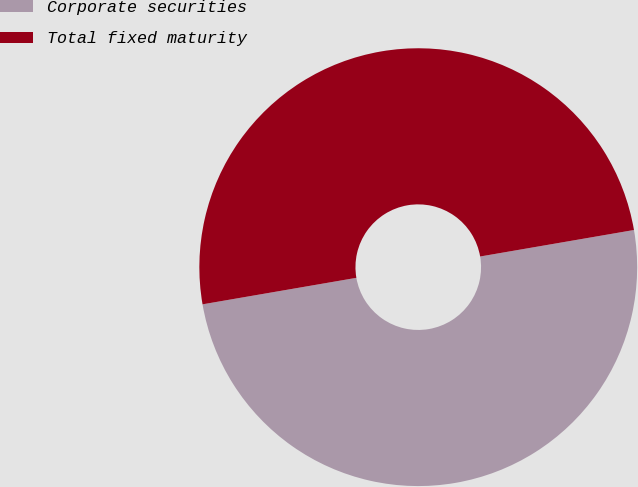<chart> <loc_0><loc_0><loc_500><loc_500><pie_chart><fcel>Corporate securities<fcel>Total fixed maturity<nl><fcel>50.0%<fcel>50.0%<nl></chart> 